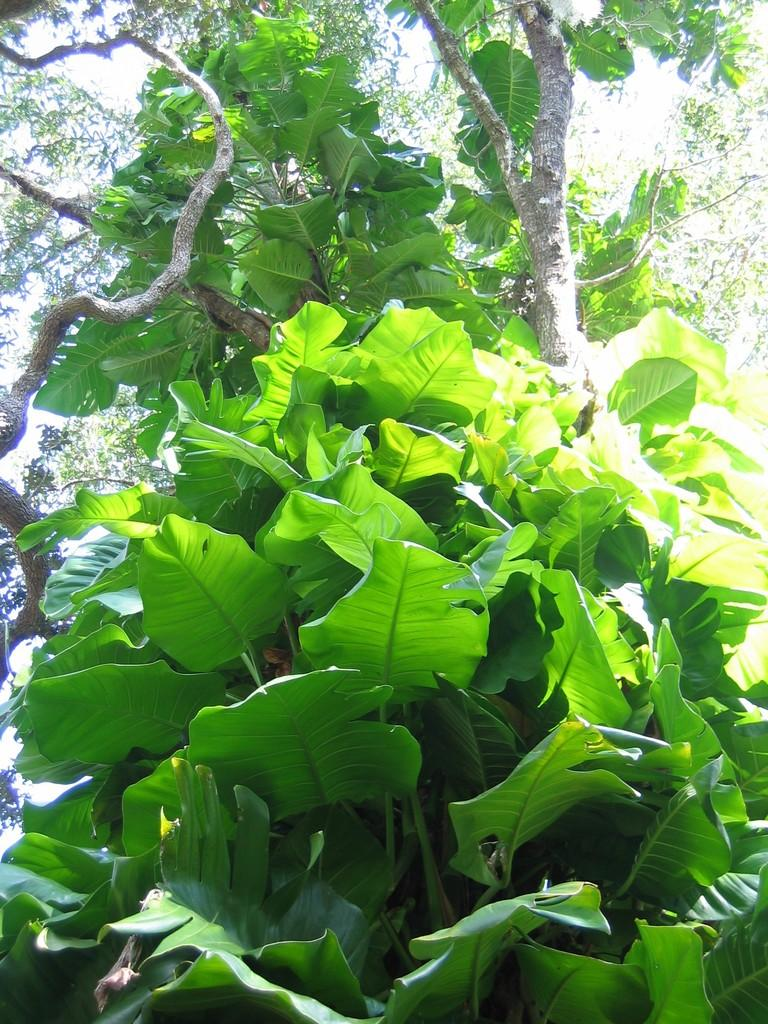What type of vegetation is in the foreground of the image? There are plants in the foreground of the image. What type of vegetation is in the background of the image? There are trees in the background of the image. What else can be seen in the background of the image? The sky is visible in the background of the image. How many basketballs can be seen hanging from the icicles in the image? There are no icicles or basketballs present in the image. 